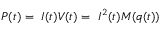<formula> <loc_0><loc_0><loc_500><loc_500>P ( t ) = \ I ( t ) V ( t ) = \ I ^ { 2 } ( t ) M ( q ( t ) )</formula> 